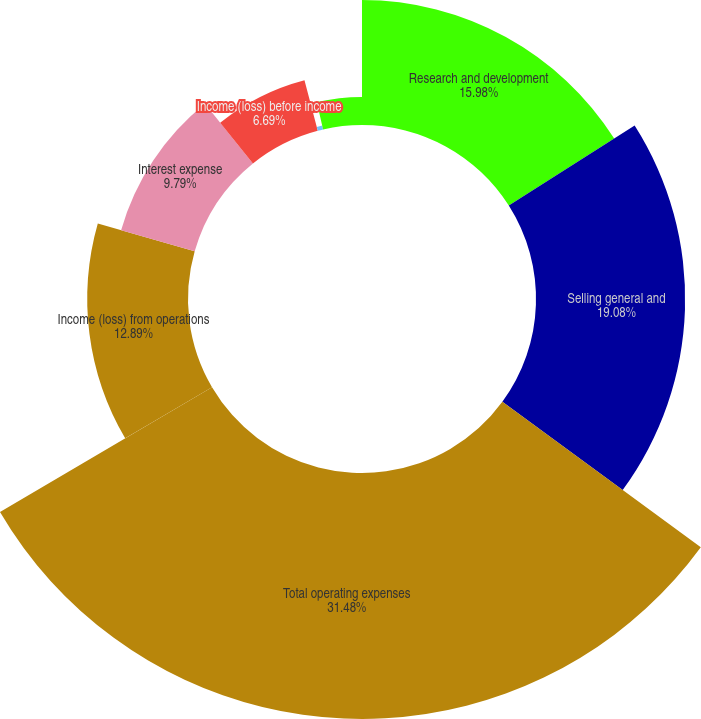Convert chart to OTSL. <chart><loc_0><loc_0><loc_500><loc_500><pie_chart><fcel>Research and development<fcel>Selling general and<fcel>Total operating expenses<fcel>Income (loss) from operations<fcel>Interest expense<fcel>Income (loss) before income<fcel>Net (loss) income<fcel>Comprehensive (loss) income<nl><fcel>15.98%<fcel>19.08%<fcel>31.47%<fcel>12.89%<fcel>9.79%<fcel>6.69%<fcel>0.5%<fcel>3.59%<nl></chart> 